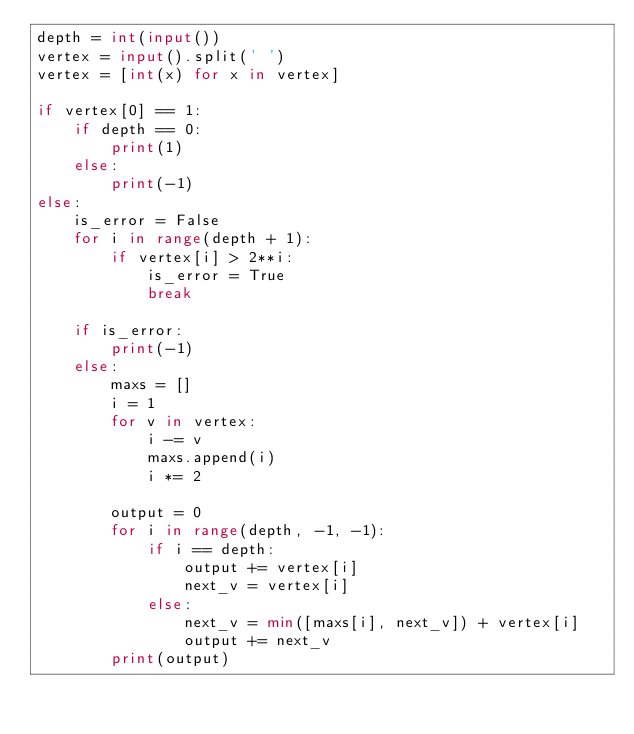Convert code to text. <code><loc_0><loc_0><loc_500><loc_500><_Python_>depth = int(input())
vertex = input().split(' ')
vertex = [int(x) for x in vertex]

if vertex[0] == 1:
    if depth == 0:
        print(1)
    else:
        print(-1)
else:
    is_error = False
    for i in range(depth + 1):
        if vertex[i] > 2**i:
            is_error = True
            break
    
    if is_error:
        print(-1)
    else:
        maxs = []
        i = 1
        for v in vertex:
            i -= v
            maxs.append(i)
            i *= 2

        output = 0
        for i in range(depth, -1, -1):
            if i == depth:
                output += vertex[i]
                next_v = vertex[i]
            else:
                next_v = min([maxs[i], next_v]) + vertex[i]
                output += next_v
        print(output)</code> 